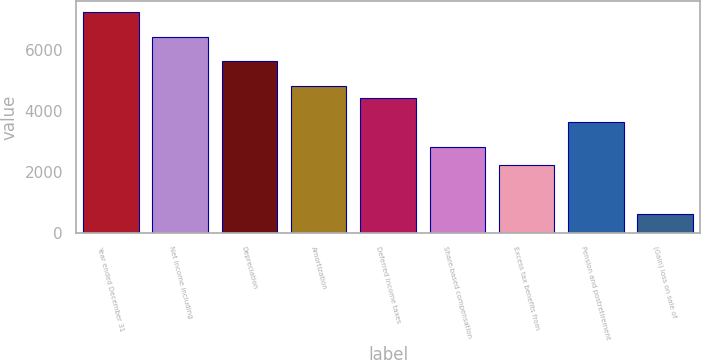Convert chart to OTSL. <chart><loc_0><loc_0><loc_500><loc_500><bar_chart><fcel>Year ended December 31<fcel>Net income including<fcel>Depreciation<fcel>Amortization<fcel>Deferred income taxes<fcel>Share-based compensation<fcel>Excess tax benefits from<fcel>Pension and postretirement<fcel>(Gain) loss on sale of<nl><fcel>7252.7<fcel>6446.9<fcel>5641.1<fcel>4835.3<fcel>4432.4<fcel>2820.8<fcel>2216.45<fcel>3626.6<fcel>604.85<nl></chart> 